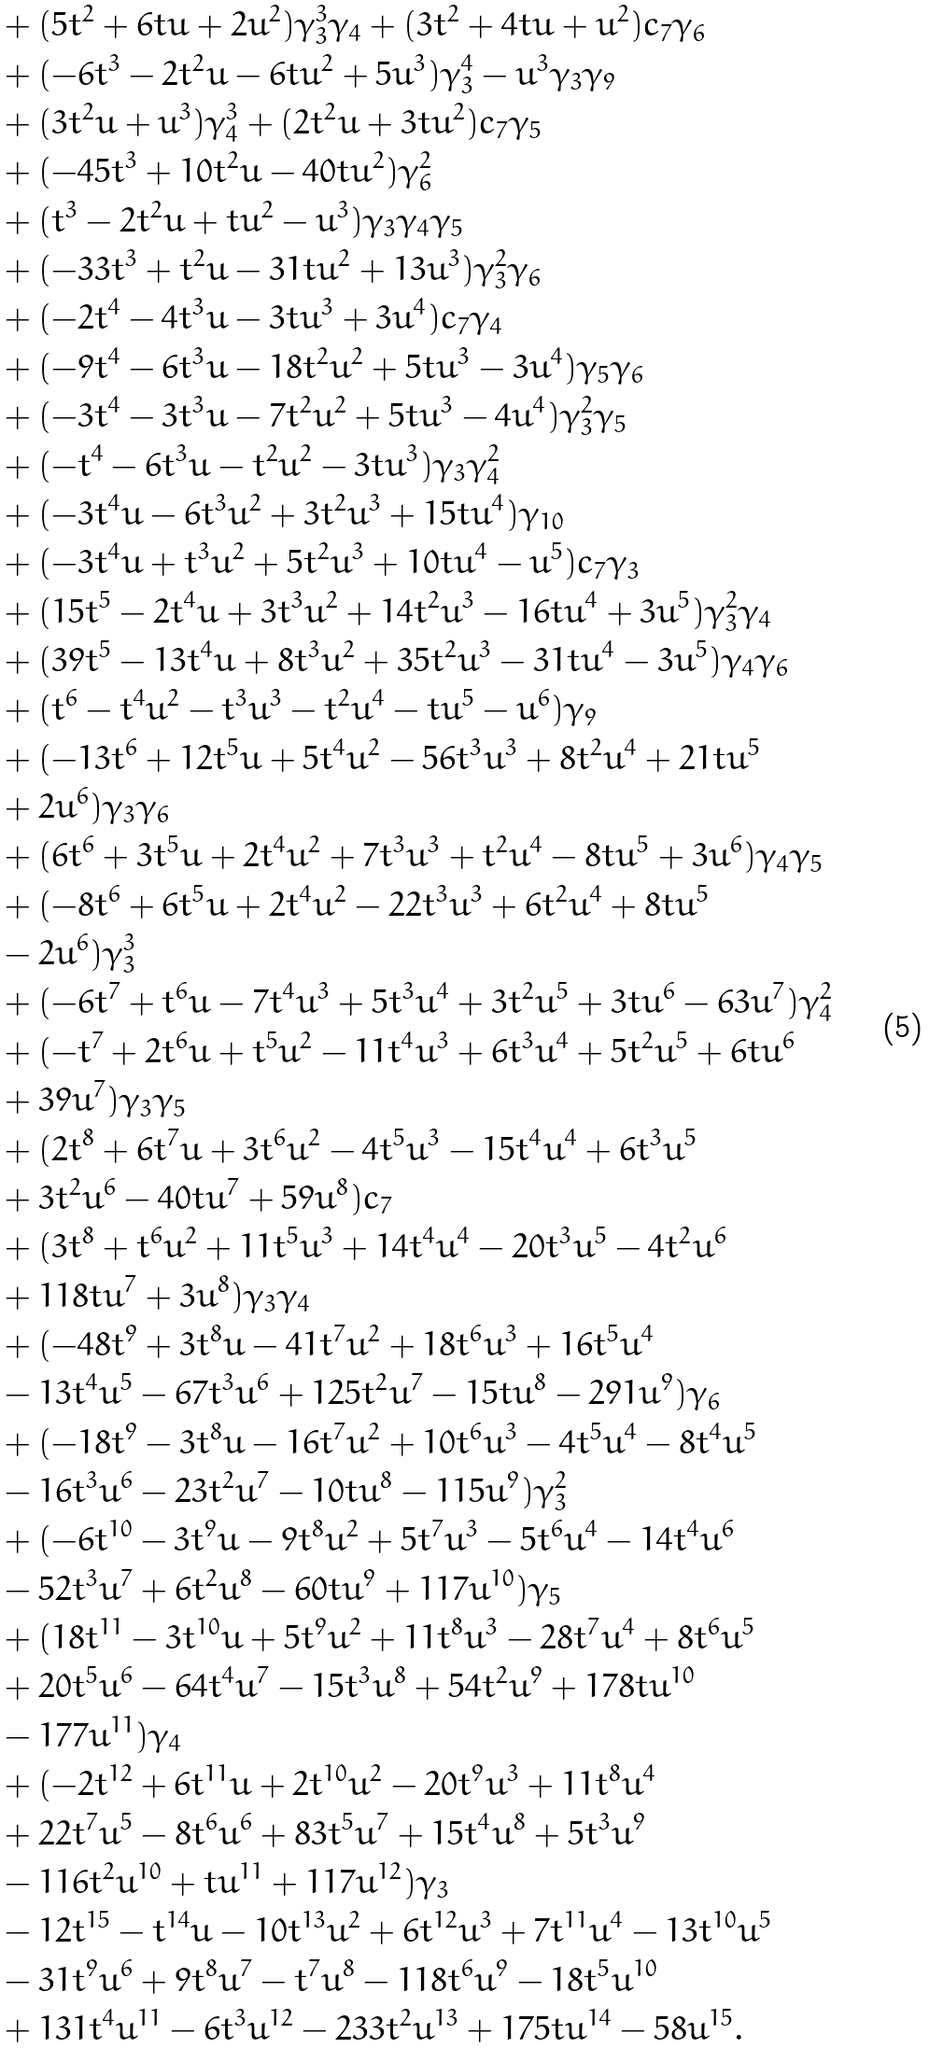<formula> <loc_0><loc_0><loc_500><loc_500>& + ( 5 t ^ { 2 } + 6 t u + 2 u ^ { 2 } ) \gamma _ { 3 } ^ { 3 } \gamma _ { 4 } + ( 3 t ^ { 2 } + 4 t u + u ^ { 2 } ) c _ { 7 } \gamma _ { 6 } \\ & + ( - 6 t ^ { 3 } - 2 t ^ { 2 } u - 6 t u ^ { 2 } + 5 u ^ { 3 } ) \gamma _ { 3 } ^ { 4 } - u ^ { 3 } \gamma _ { 3 } \gamma _ { 9 } \\ & + ( 3 t ^ { 2 } u + u ^ { 3 } ) \gamma _ { 4 } ^ { 3 } + ( 2 t ^ { 2 } u + 3 t u ^ { 2 } ) c _ { 7 } \gamma _ { 5 } \\ & + ( - 4 5 t ^ { 3 } + 1 0 t ^ { 2 } u - 4 0 t u ^ { 2 } ) \gamma _ { 6 } ^ { 2 } \\ & + ( t ^ { 3 } - 2 t ^ { 2 } u + t u ^ { 2 } - u ^ { 3 } ) \gamma _ { 3 } \gamma _ { 4 } \gamma _ { 5 } \\ & + ( - 3 3 t ^ { 3 } + t ^ { 2 } u - 3 1 t u ^ { 2 } + 1 3 u ^ { 3 } ) \gamma _ { 3 } ^ { 2 } \gamma _ { 6 } \\ & + ( - 2 t ^ { 4 } - 4 t ^ { 3 } u - 3 t u ^ { 3 } + 3 u ^ { 4 } ) c _ { 7 } \gamma _ { 4 } \\ & + ( - 9 t ^ { 4 } - 6 t ^ { 3 } u - 1 8 t ^ { 2 } u ^ { 2 } + 5 t u ^ { 3 } - 3 u ^ { 4 } ) \gamma _ { 5 } \gamma _ { 6 } \\ & + ( - 3 t ^ { 4 } - 3 t ^ { 3 } u - 7 t ^ { 2 } u ^ { 2 } + 5 t u ^ { 3 } - 4 u ^ { 4 } ) \gamma _ { 3 } ^ { 2 } \gamma _ { 5 } \\ & + ( - t ^ { 4 } - 6 t ^ { 3 } u - t ^ { 2 } u ^ { 2 } - 3 t u ^ { 3 } ) \gamma _ { 3 } \gamma _ { 4 } ^ { 2 } \\ & + ( - 3 t ^ { 4 } u - 6 t ^ { 3 } u ^ { 2 } + 3 t ^ { 2 } u ^ { 3 } + 1 5 t u ^ { 4 } ) \gamma _ { 1 0 } \\ & + ( - 3 t ^ { 4 } u + t ^ { 3 } u ^ { 2 } + 5 t ^ { 2 } u ^ { 3 } + 1 0 t u ^ { 4 } - u ^ { 5 } ) c _ { 7 } \gamma _ { 3 } \\ & + ( 1 5 t ^ { 5 } - 2 t ^ { 4 } u + 3 t ^ { 3 } u ^ { 2 } + 1 4 t ^ { 2 } u ^ { 3 } - 1 6 t u ^ { 4 } + 3 u ^ { 5 } ) \gamma _ { 3 } ^ { 2 } \gamma _ { 4 } \\ & + ( 3 9 t ^ { 5 } - 1 3 t ^ { 4 } u + 8 t ^ { 3 } u ^ { 2 } + 3 5 t ^ { 2 } u ^ { 3 } - 3 1 t u ^ { 4 } - 3 u ^ { 5 } ) \gamma _ { 4 } \gamma _ { 6 } \\ & + ( t ^ { 6 } - t ^ { 4 } u ^ { 2 } - { t } ^ { 3 } { u } ^ { 3 } - t ^ { 2 } u ^ { 4 } - t u ^ { 5 } - u ^ { 6 } ) \gamma _ { 9 } \\ & + ( - 1 3 t ^ { 6 } + 1 2 t ^ { 5 } u + 5 t ^ { 4 } u ^ { 2 } - 5 6 t ^ { 3 } u ^ { 3 } + 8 t ^ { 2 } u ^ { 4 } + 2 1 t u ^ { 5 } \\ & + 2 u ^ { 6 } ) \gamma _ { 3 } \gamma _ { 6 } \\ & + ( 6 t ^ { 6 } + 3 t ^ { 5 } u + 2 t ^ { 4 } u ^ { 2 } + 7 t ^ { 3 } u ^ { 3 } + t ^ { 2 } u ^ { 4 } - 8 t u ^ { 5 } + 3 u ^ { 6 } ) \gamma _ { 4 } \gamma _ { 5 } \\ & + ( - 8 t ^ { 6 } + 6 t ^ { 5 } u + 2 t ^ { 4 } u ^ { 2 } - 2 2 t ^ { 3 } u ^ { 3 } + 6 t ^ { 2 } u ^ { 4 } + 8 t u ^ { 5 } \\ & - 2 u ^ { 6 } ) \gamma _ { 3 } ^ { 3 } \\ & + ( - 6 t ^ { 7 } + t ^ { 6 } u - 7 t ^ { 4 } u ^ { 3 } + 5 t ^ { 3 } u ^ { 4 } + 3 t ^ { 2 } u ^ { 5 } + 3 t u ^ { 6 } - 6 3 u ^ { 7 } ) \gamma _ { 4 } ^ { 2 } \\ & + ( - t ^ { 7 } + 2 t ^ { 6 } u + t ^ { 5 } u ^ { 2 } - 1 1 t ^ { 4 } u ^ { 3 } + 6 t ^ { 3 } u ^ { 4 } + 5 t ^ { 2 } u ^ { 5 } + 6 t u ^ { 6 } \\ & + 3 9 u ^ { 7 } ) \gamma _ { 3 } \gamma _ { 5 } \\ & + ( 2 t ^ { 8 } + 6 t ^ { 7 } u + 3 t ^ { 6 } u ^ { 2 } - 4 t ^ { 5 } u ^ { 3 } - 1 5 t ^ { 4 } u ^ { 4 } + 6 t ^ { 3 } u ^ { 5 } \\ & + 3 t ^ { 2 } u ^ { 6 } - 4 0 t u ^ { 7 } + 5 9 u ^ { 8 } ) c _ { 7 } \\ & + ( 3 t ^ { 8 } + t ^ { 6 } u ^ { 2 } + 1 1 t ^ { 5 } u ^ { 3 } + 1 4 t ^ { 4 } u ^ { 4 } - 2 0 t ^ { 3 } u ^ { 5 } - 4 t ^ { 2 } u ^ { 6 } \\ & + 1 1 8 t u ^ { 7 } + 3 u ^ { 8 } ) \gamma _ { 3 } \gamma _ { 4 } \\ & + ( - 4 8 t ^ { 9 } + 3 t ^ { 8 } u - 4 1 t ^ { 7 } u ^ { 2 } + 1 8 t ^ { 6 } u ^ { 3 } + 1 6 t ^ { 5 } u ^ { 4 } \\ & - 1 3 t ^ { 4 } u ^ { 5 } - 6 7 t ^ { 3 } u ^ { 6 } + 1 2 5 t ^ { 2 } u ^ { 7 } - 1 5 t u ^ { 8 } - 2 9 1 u ^ { 9 } ) \gamma _ { 6 } \\ & + ( - 1 8 t ^ { 9 } - 3 t ^ { 8 } u - 1 6 t ^ { 7 } u ^ { 2 } + 1 0 t ^ { 6 } u ^ { 3 } - 4 t ^ { 5 } u ^ { 4 } - 8 t ^ { 4 } u ^ { 5 } \\ & - 1 6 t ^ { 3 } u ^ { 6 } - 2 3 t ^ { 2 } u ^ { 7 } - 1 0 t u ^ { 8 } - 1 1 5 u ^ { 9 } ) \gamma _ { 3 } ^ { 2 } \\ & + ( - 6 t ^ { 1 0 } - 3 t ^ { 9 } u - 9 t ^ { 8 } u ^ { 2 } + 5 t ^ { 7 } u ^ { 3 } - 5 t ^ { 6 } u ^ { 4 } - 1 4 t ^ { 4 } u ^ { 6 } \\ & - 5 2 t ^ { 3 } u ^ { 7 } + 6 t ^ { 2 } u ^ { 8 } - 6 0 t u ^ { 9 } + 1 1 7 u ^ { 1 0 } ) \gamma _ { 5 } \\ & + ( 1 8 t ^ { 1 1 } - 3 t ^ { 1 0 } u + 5 t ^ { 9 } u ^ { 2 } + 1 1 t ^ { 8 } u ^ { 3 } - 2 8 t ^ { 7 } u ^ { 4 } + 8 t ^ { 6 } u ^ { 5 } \\ & + 2 0 t ^ { 5 } u ^ { 6 } - 6 4 t ^ { 4 } u ^ { 7 } - 1 5 t ^ { 3 } u ^ { 8 } + 5 4 t ^ { 2 } u ^ { 9 } + 1 7 8 t u ^ { 1 0 } \\ & - 1 7 7 u ^ { 1 1 } ) \gamma _ { 4 } \\ & + ( - 2 t ^ { 1 2 } + 6 t ^ { 1 1 } u + 2 t ^ { 1 0 } u ^ { 2 } - 2 0 t ^ { 9 } u ^ { 3 } + 1 1 t ^ { 8 } u ^ { 4 } \\ & + 2 2 t ^ { 7 } u ^ { 5 } - 8 t ^ { 6 } u ^ { 6 } + 8 3 t ^ { 5 } u ^ { 7 } + 1 5 t ^ { 4 } u ^ { 8 } + 5 t ^ { 3 } u ^ { 9 } \\ & - 1 1 6 t ^ { 2 } u ^ { 1 0 } + t u ^ { 1 1 } + 1 1 7 u ^ { 1 2 } ) \gamma _ { 3 } \\ & - 1 2 t ^ { 1 5 } - t ^ { 1 4 } u - 1 0 t ^ { 1 3 } u ^ { 2 } + 6 t ^ { 1 2 } u ^ { 3 } + 7 t ^ { 1 1 } u ^ { 4 } - 1 3 t ^ { 1 0 } u ^ { 5 } \\ & - 3 1 t ^ { 9 } u ^ { 6 } + 9 t ^ { 8 } u ^ { 7 } - t ^ { 7 } u ^ { 8 } - 1 1 8 t ^ { 6 } u ^ { 9 } - 1 8 t ^ { 5 } u ^ { 1 0 } \\ & + 1 3 1 t ^ { 4 } u ^ { 1 1 } - 6 t ^ { 3 } u ^ { 1 2 } - 2 3 3 t ^ { 2 } u ^ { 1 3 } + 1 7 5 t u ^ { 1 4 } - 5 8 u ^ { 1 5 } .</formula> 